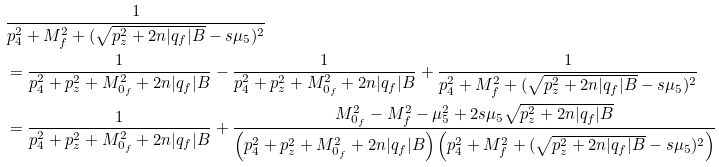Convert formula to latex. <formula><loc_0><loc_0><loc_500><loc_500>& \frac { 1 } { p _ { 4 } ^ { 2 } + M _ { f } ^ { 2 } + ( \sqrt { p _ { z } ^ { 2 } + 2 n | q _ { f } | B } - s \mu _ { 5 } ) ^ { 2 } } \\ & = \frac { 1 } { p _ { 4 } ^ { 2 } + p _ { z } ^ { 2 } + M _ { 0 _ { f } } ^ { 2 } + 2 n | q _ { f } | B } - \frac { 1 } { p _ { 4 } ^ { 2 } + p _ { z } ^ { 2 } + M _ { 0 _ { f } } ^ { 2 } + 2 n | q _ { f } | B } + \frac { 1 } { p _ { 4 } ^ { 2 } + M _ { f } ^ { 2 } + ( \sqrt { p _ { z } ^ { 2 } + 2 n | q _ { f } | B } - s \mu _ { 5 } ) ^ { 2 } } \\ & = \frac { 1 } { p _ { 4 } ^ { 2 } + p _ { z } ^ { 2 } + M _ { 0 _ { f } } ^ { 2 } + 2 n | q _ { f } | B } + \frac { M _ { 0 _ { f } } ^ { 2 } - M _ { f } ^ { 2 } - \mu _ { 5 } ^ { 2 } + 2 s \mu _ { 5 } \sqrt { p _ { z } ^ { 2 } + 2 n | q _ { f } | B } } { \left ( p _ { 4 } ^ { 2 } + p _ { z } ^ { 2 } + M _ { 0 _ { f } } ^ { 2 } + 2 n | q _ { f } | B \right ) \left ( p _ { 4 } ^ { 2 } + M _ { f } ^ { 2 } + ( \sqrt { p _ { z } ^ { 2 } + 2 n | q _ { f } | B } - s \mu _ { 5 } ) ^ { 2 } \right ) }</formula> 